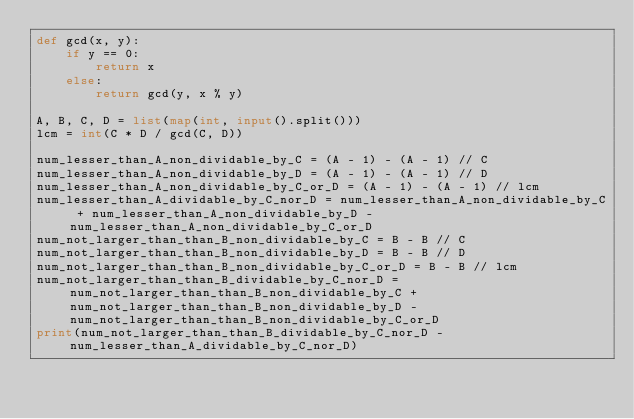Convert code to text. <code><loc_0><loc_0><loc_500><loc_500><_Python_>def gcd(x, y):
    if y == 0:
        return x
    else:
        return gcd(y, x % y)

A, B, C, D = list(map(int, input().split()))
lcm = int(C * D / gcd(C, D))

num_lesser_than_A_non_dividable_by_C = (A - 1) - (A - 1) // C
num_lesser_than_A_non_dividable_by_D = (A - 1) - (A - 1) // D
num_lesser_than_A_non_dividable_by_C_or_D = (A - 1) - (A - 1) // lcm
num_lesser_than_A_dividable_by_C_nor_D = num_lesser_than_A_non_dividable_by_C + num_lesser_than_A_non_dividable_by_D - num_lesser_than_A_non_dividable_by_C_or_D
num_not_larger_than_than_B_non_dividable_by_C = B - B // C
num_not_larger_than_than_B_non_dividable_by_D = B - B // D
num_not_larger_than_than_B_non_dividable_by_C_or_D = B - B // lcm
num_not_larger_than_than_B_dividable_by_C_nor_D = num_not_larger_than_than_B_non_dividable_by_C + num_not_larger_than_than_B_non_dividable_by_D - num_not_larger_than_than_B_non_dividable_by_C_or_D
print(num_not_larger_than_than_B_dividable_by_C_nor_D - num_lesser_than_A_dividable_by_C_nor_D)</code> 